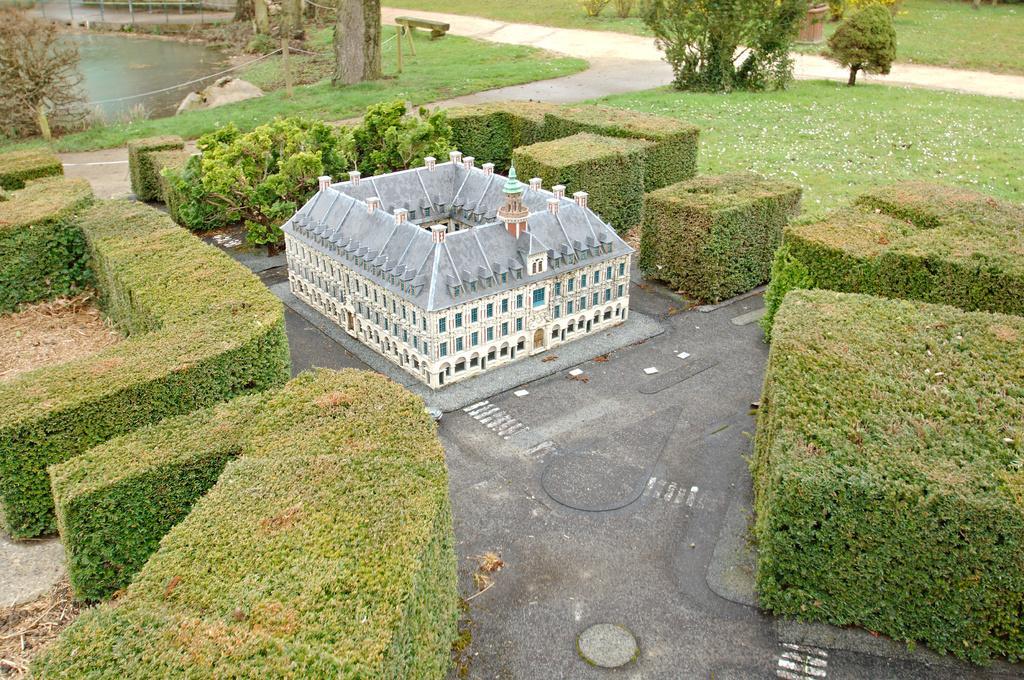Describe this image in one or two sentences. This is a building with the windows. I think these are the bushes and trees. Here is the grass. This looks like a pathway. I can see a bench. I think this is a pond with the water. I can see a rock. 